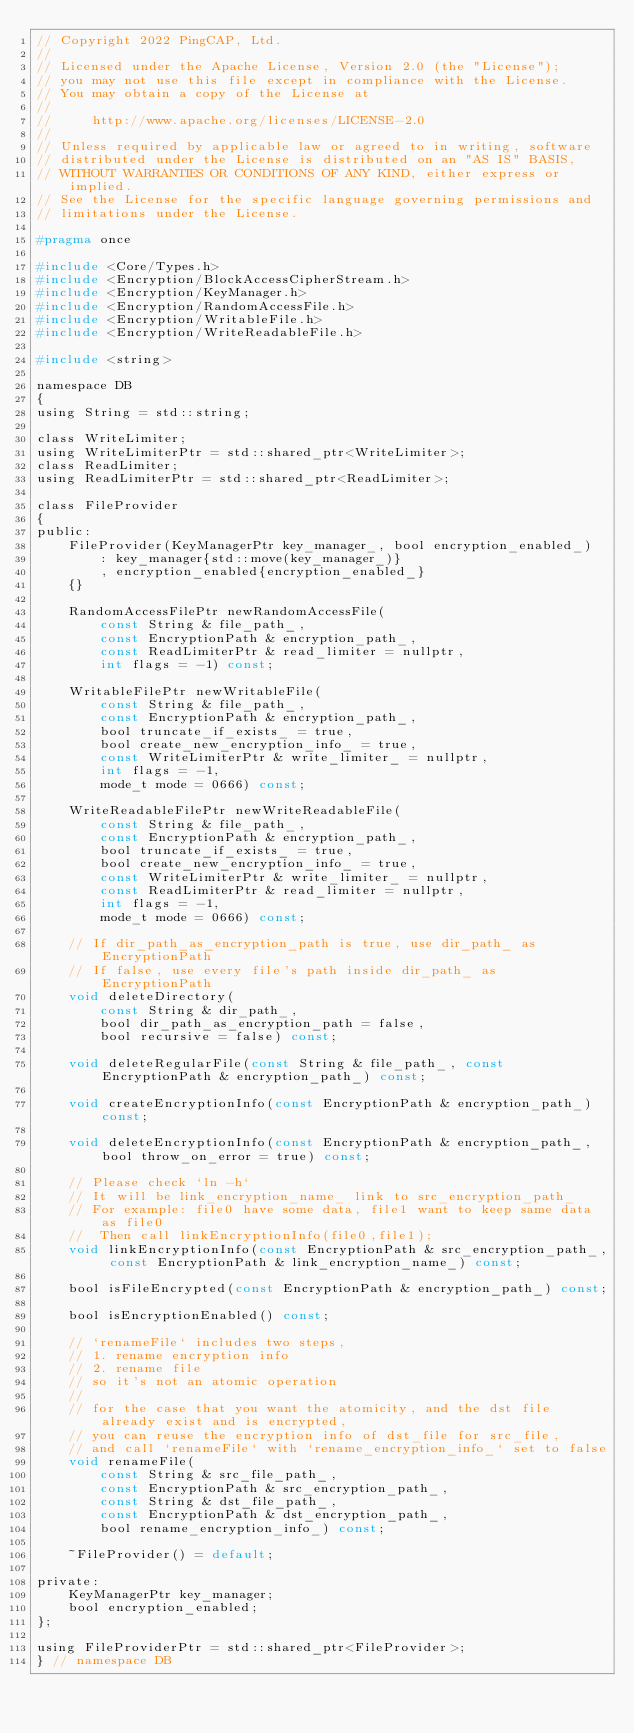Convert code to text. <code><loc_0><loc_0><loc_500><loc_500><_C_>// Copyright 2022 PingCAP, Ltd.
//
// Licensed under the Apache License, Version 2.0 (the "License");
// you may not use this file except in compliance with the License.
// You may obtain a copy of the License at
//
//     http://www.apache.org/licenses/LICENSE-2.0
//
// Unless required by applicable law or agreed to in writing, software
// distributed under the License is distributed on an "AS IS" BASIS,
// WITHOUT WARRANTIES OR CONDITIONS OF ANY KIND, either express or implied.
// See the License for the specific language governing permissions and
// limitations under the License.

#pragma once

#include <Core/Types.h>
#include <Encryption/BlockAccessCipherStream.h>
#include <Encryption/KeyManager.h>
#include <Encryption/RandomAccessFile.h>
#include <Encryption/WritableFile.h>
#include <Encryption/WriteReadableFile.h>

#include <string>

namespace DB
{
using String = std::string;

class WriteLimiter;
using WriteLimiterPtr = std::shared_ptr<WriteLimiter>;
class ReadLimiter;
using ReadLimiterPtr = std::shared_ptr<ReadLimiter>;

class FileProvider
{
public:
    FileProvider(KeyManagerPtr key_manager_, bool encryption_enabled_)
        : key_manager{std::move(key_manager_)}
        , encryption_enabled{encryption_enabled_}
    {}

    RandomAccessFilePtr newRandomAccessFile(
        const String & file_path_,
        const EncryptionPath & encryption_path_,
        const ReadLimiterPtr & read_limiter = nullptr,
        int flags = -1) const;

    WritableFilePtr newWritableFile(
        const String & file_path_,
        const EncryptionPath & encryption_path_,
        bool truncate_if_exists_ = true,
        bool create_new_encryption_info_ = true,
        const WriteLimiterPtr & write_limiter_ = nullptr,
        int flags = -1,
        mode_t mode = 0666) const;

    WriteReadableFilePtr newWriteReadableFile(
        const String & file_path_,
        const EncryptionPath & encryption_path_,
        bool truncate_if_exists_ = true,
        bool create_new_encryption_info_ = true,
        const WriteLimiterPtr & write_limiter_ = nullptr,
        const ReadLimiterPtr & read_limiter = nullptr,
        int flags = -1,
        mode_t mode = 0666) const;

    // If dir_path_as_encryption_path is true, use dir_path_ as EncryptionPath
    // If false, use every file's path inside dir_path_ as EncryptionPath
    void deleteDirectory(
        const String & dir_path_,
        bool dir_path_as_encryption_path = false,
        bool recursive = false) const;

    void deleteRegularFile(const String & file_path_, const EncryptionPath & encryption_path_) const;

    void createEncryptionInfo(const EncryptionPath & encryption_path_) const;

    void deleteEncryptionInfo(const EncryptionPath & encryption_path_, bool throw_on_error = true) const;

    // Please check `ln -h`
    // It will be link_encryption_name_ link to src_encryption_path_
    // For example: file0 have some data, file1 want to keep same data as file0
    //  Then call linkEncryptionInfo(file0,file1);
    void linkEncryptionInfo(const EncryptionPath & src_encryption_path_, const EncryptionPath & link_encryption_name_) const;

    bool isFileEncrypted(const EncryptionPath & encryption_path_) const;

    bool isEncryptionEnabled() const;

    // `renameFile` includes two steps,
    // 1. rename encryption info
    // 2. rename file
    // so it's not an atomic operation
    //
    // for the case that you want the atomicity, and the dst file already exist and is encrypted,
    // you can reuse the encryption info of dst_file for src_file,
    // and call `renameFile` with `rename_encryption_info_` set to false
    void renameFile(
        const String & src_file_path_,
        const EncryptionPath & src_encryption_path_,
        const String & dst_file_path_,
        const EncryptionPath & dst_encryption_path_,
        bool rename_encryption_info_) const;

    ~FileProvider() = default;

private:
    KeyManagerPtr key_manager;
    bool encryption_enabled;
};

using FileProviderPtr = std::shared_ptr<FileProvider>;
} // namespace DB
</code> 